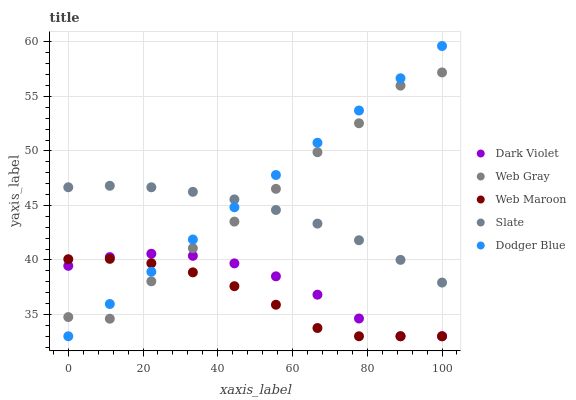Does Web Maroon have the minimum area under the curve?
Answer yes or no. Yes. Does Dodger Blue have the maximum area under the curve?
Answer yes or no. Yes. Does Slate have the minimum area under the curve?
Answer yes or no. No. Does Slate have the maximum area under the curve?
Answer yes or no. No. Is Dodger Blue the smoothest?
Answer yes or no. Yes. Is Web Gray the roughest?
Answer yes or no. Yes. Is Slate the smoothest?
Answer yes or no. No. Is Slate the roughest?
Answer yes or no. No. Does Dodger Blue have the lowest value?
Answer yes or no. Yes. Does Web Gray have the lowest value?
Answer yes or no. No. Does Dodger Blue have the highest value?
Answer yes or no. Yes. Does Slate have the highest value?
Answer yes or no. No. Is Web Maroon less than Slate?
Answer yes or no. Yes. Is Slate greater than Dark Violet?
Answer yes or no. Yes. Does Dodger Blue intersect Slate?
Answer yes or no. Yes. Is Dodger Blue less than Slate?
Answer yes or no. No. Is Dodger Blue greater than Slate?
Answer yes or no. No. Does Web Maroon intersect Slate?
Answer yes or no. No. 